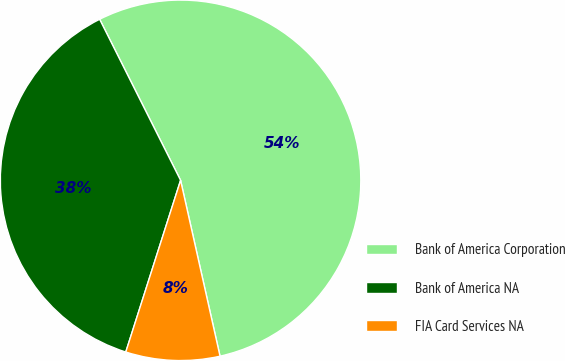Convert chart to OTSL. <chart><loc_0><loc_0><loc_500><loc_500><pie_chart><fcel>Bank of America Corporation<fcel>Bank of America NA<fcel>FIA Card Services NA<nl><fcel>53.9%<fcel>37.67%<fcel>8.43%<nl></chart> 